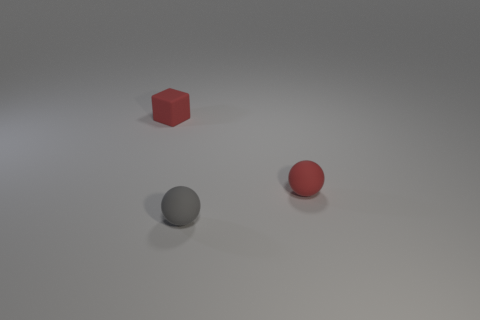Add 1 gray objects. How many objects exist? 4 Subtract all blocks. How many objects are left? 2 Add 1 red balls. How many red balls are left? 2 Add 3 red matte things. How many red matte things exist? 5 Subtract 0 purple blocks. How many objects are left? 3 Subtract all red matte spheres. Subtract all small red blocks. How many objects are left? 1 